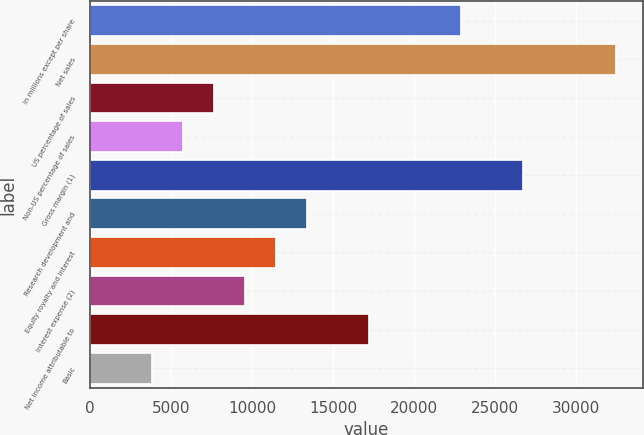Convert chart to OTSL. <chart><loc_0><loc_0><loc_500><loc_500><bar_chart><fcel>In millions except per share<fcel>Net sales<fcel>US percentage of sales<fcel>Non-US percentage of sales<fcel>Gross margin (1)<fcel>Research development and<fcel>Equity royalty and interest<fcel>Interest expense (2)<fcel>Net income attributable to<fcel>Basic<nl><fcel>22931.3<fcel>32484.6<fcel>7646.11<fcel>5735.46<fcel>26752.6<fcel>13378.1<fcel>11467.4<fcel>9556.76<fcel>17199.4<fcel>3824.81<nl></chart> 